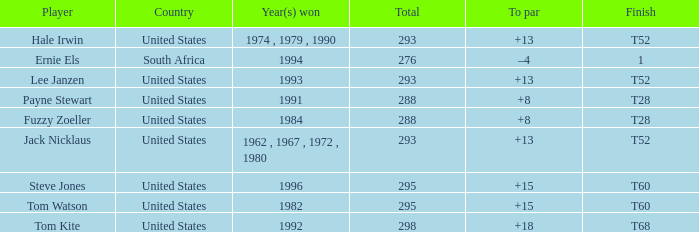What is the average total of player hale irwin, who had a t52 finish? 293.0. 